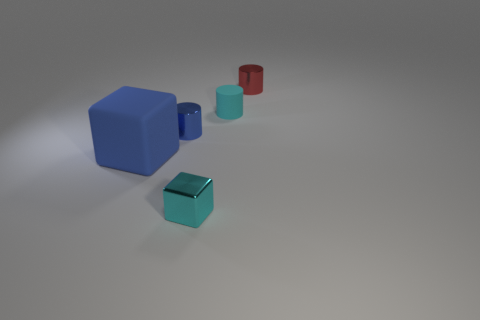There is a metallic object that is the same color as the small matte cylinder; what is its shape?
Make the answer very short. Cube. How many things are big cyan matte blocks or tiny cyan objects behind the tiny blue cylinder?
Give a very brief answer. 1. There is a metal cylinder that is in front of the red metal cylinder; is it the same size as the tiny cyan rubber cylinder?
Make the answer very short. Yes. What is the small cyan thing that is right of the tiny cyan metal cube made of?
Offer a very short reply. Rubber. Are there an equal number of tiny matte cylinders that are on the left side of the blue matte block and small cyan shiny cubes to the right of the cyan cylinder?
Your answer should be compact. Yes. What color is the other rubber thing that is the same shape as the small blue thing?
Ensure brevity in your answer.  Cyan. Is there anything else of the same color as the matte cube?
Your answer should be compact. Yes. How many shiny things are either small blue cylinders or tiny cyan objects?
Offer a very short reply. 2. Is the large rubber thing the same color as the tiny shiny cube?
Your response must be concise. No. Are there more rubber things behind the big rubber object than cyan rubber objects?
Give a very brief answer. No. 